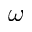<formula> <loc_0><loc_0><loc_500><loc_500>\omega</formula> 